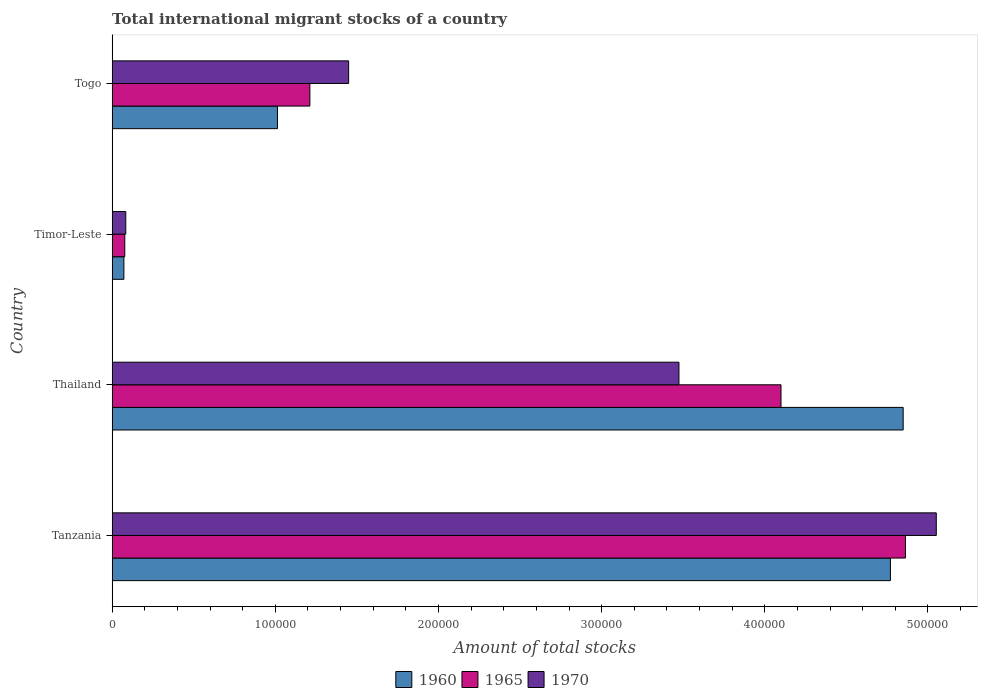How many different coloured bars are there?
Make the answer very short. 3. How many groups of bars are there?
Your answer should be compact. 4. Are the number of bars per tick equal to the number of legend labels?
Provide a succinct answer. Yes. Are the number of bars on each tick of the Y-axis equal?
Provide a succinct answer. Yes. How many bars are there on the 3rd tick from the bottom?
Offer a terse response. 3. What is the label of the 3rd group of bars from the top?
Provide a succinct answer. Thailand. What is the amount of total stocks in in 1965 in Togo?
Give a very brief answer. 1.21e+05. Across all countries, what is the maximum amount of total stocks in in 1965?
Your answer should be very brief. 4.86e+05. Across all countries, what is the minimum amount of total stocks in in 1965?
Ensure brevity in your answer.  7705. In which country was the amount of total stocks in in 1970 maximum?
Your response must be concise. Tanzania. In which country was the amount of total stocks in in 1965 minimum?
Offer a very short reply. Timor-Leste. What is the total amount of total stocks in in 1970 in the graph?
Provide a succinct answer. 1.01e+06. What is the difference between the amount of total stocks in in 1960 in Tanzania and that in Timor-Leste?
Make the answer very short. 4.70e+05. What is the difference between the amount of total stocks in in 1970 in Thailand and the amount of total stocks in in 1965 in Timor-Leste?
Offer a very short reply. 3.40e+05. What is the average amount of total stocks in in 1960 per country?
Provide a short and direct response. 2.68e+05. What is the difference between the amount of total stocks in in 1970 and amount of total stocks in in 1960 in Tanzania?
Provide a succinct answer. 2.81e+04. In how many countries, is the amount of total stocks in in 1965 greater than 260000 ?
Offer a terse response. 2. What is the ratio of the amount of total stocks in in 1970 in Thailand to that in Togo?
Your answer should be very brief. 2.4. What is the difference between the highest and the second highest amount of total stocks in in 1965?
Keep it short and to the point. 7.63e+04. What is the difference between the highest and the lowest amount of total stocks in in 1965?
Your answer should be compact. 4.79e+05. In how many countries, is the amount of total stocks in in 1965 greater than the average amount of total stocks in in 1965 taken over all countries?
Ensure brevity in your answer.  2. Is the sum of the amount of total stocks in in 1965 in Tanzania and Timor-Leste greater than the maximum amount of total stocks in in 1970 across all countries?
Ensure brevity in your answer.  No. How many bars are there?
Provide a short and direct response. 12. How many countries are there in the graph?
Your response must be concise. 4. Are the values on the major ticks of X-axis written in scientific E-notation?
Make the answer very short. No. Does the graph contain any zero values?
Provide a succinct answer. No. Does the graph contain grids?
Ensure brevity in your answer.  No. Where does the legend appear in the graph?
Ensure brevity in your answer.  Bottom center. How are the legend labels stacked?
Provide a succinct answer. Horizontal. What is the title of the graph?
Make the answer very short. Total international migrant stocks of a country. Does "1962" appear as one of the legend labels in the graph?
Your response must be concise. No. What is the label or title of the X-axis?
Offer a terse response. Amount of total stocks. What is the label or title of the Y-axis?
Offer a terse response. Country. What is the Amount of total stocks of 1960 in Tanzania?
Give a very brief answer. 4.77e+05. What is the Amount of total stocks in 1965 in Tanzania?
Provide a succinct answer. 4.86e+05. What is the Amount of total stocks in 1970 in Tanzania?
Provide a succinct answer. 5.05e+05. What is the Amount of total stocks of 1960 in Thailand?
Give a very brief answer. 4.85e+05. What is the Amount of total stocks in 1965 in Thailand?
Offer a very short reply. 4.10e+05. What is the Amount of total stocks of 1970 in Thailand?
Keep it short and to the point. 3.47e+05. What is the Amount of total stocks in 1960 in Timor-Leste?
Make the answer very short. 7148. What is the Amount of total stocks of 1965 in Timor-Leste?
Provide a succinct answer. 7705. What is the Amount of total stocks in 1970 in Timor-Leste?
Offer a very short reply. 8306. What is the Amount of total stocks in 1960 in Togo?
Ensure brevity in your answer.  1.01e+05. What is the Amount of total stocks of 1965 in Togo?
Provide a short and direct response. 1.21e+05. What is the Amount of total stocks in 1970 in Togo?
Offer a very short reply. 1.45e+05. Across all countries, what is the maximum Amount of total stocks in 1960?
Your response must be concise. 4.85e+05. Across all countries, what is the maximum Amount of total stocks in 1965?
Give a very brief answer. 4.86e+05. Across all countries, what is the maximum Amount of total stocks of 1970?
Provide a short and direct response. 5.05e+05. Across all countries, what is the minimum Amount of total stocks of 1960?
Your response must be concise. 7148. Across all countries, what is the minimum Amount of total stocks of 1965?
Offer a terse response. 7705. Across all countries, what is the minimum Amount of total stocks of 1970?
Offer a terse response. 8306. What is the total Amount of total stocks of 1960 in the graph?
Keep it short and to the point. 1.07e+06. What is the total Amount of total stocks of 1965 in the graph?
Offer a terse response. 1.03e+06. What is the total Amount of total stocks in 1970 in the graph?
Your answer should be compact. 1.01e+06. What is the difference between the Amount of total stocks of 1960 in Tanzania and that in Thailand?
Your answer should be very brief. -7812. What is the difference between the Amount of total stocks in 1965 in Tanzania and that in Thailand?
Make the answer very short. 7.63e+04. What is the difference between the Amount of total stocks of 1970 in Tanzania and that in Thailand?
Your response must be concise. 1.58e+05. What is the difference between the Amount of total stocks of 1960 in Tanzania and that in Timor-Leste?
Make the answer very short. 4.70e+05. What is the difference between the Amount of total stocks of 1965 in Tanzania and that in Timor-Leste?
Ensure brevity in your answer.  4.79e+05. What is the difference between the Amount of total stocks of 1970 in Tanzania and that in Timor-Leste?
Offer a very short reply. 4.97e+05. What is the difference between the Amount of total stocks in 1960 in Tanzania and that in Togo?
Ensure brevity in your answer.  3.76e+05. What is the difference between the Amount of total stocks in 1965 in Tanzania and that in Togo?
Provide a short and direct response. 3.65e+05. What is the difference between the Amount of total stocks of 1970 in Tanzania and that in Togo?
Your response must be concise. 3.60e+05. What is the difference between the Amount of total stocks in 1960 in Thailand and that in Timor-Leste?
Give a very brief answer. 4.78e+05. What is the difference between the Amount of total stocks in 1965 in Thailand and that in Timor-Leste?
Your answer should be very brief. 4.02e+05. What is the difference between the Amount of total stocks in 1970 in Thailand and that in Timor-Leste?
Offer a terse response. 3.39e+05. What is the difference between the Amount of total stocks in 1960 in Thailand and that in Togo?
Provide a succinct answer. 3.84e+05. What is the difference between the Amount of total stocks of 1965 in Thailand and that in Togo?
Offer a terse response. 2.89e+05. What is the difference between the Amount of total stocks of 1970 in Thailand and that in Togo?
Give a very brief answer. 2.02e+05. What is the difference between the Amount of total stocks in 1960 in Timor-Leste and that in Togo?
Your response must be concise. -9.41e+04. What is the difference between the Amount of total stocks in 1965 in Timor-Leste and that in Togo?
Provide a short and direct response. -1.13e+05. What is the difference between the Amount of total stocks in 1970 in Timor-Leste and that in Togo?
Your response must be concise. -1.37e+05. What is the difference between the Amount of total stocks of 1960 in Tanzania and the Amount of total stocks of 1965 in Thailand?
Your answer should be very brief. 6.71e+04. What is the difference between the Amount of total stocks in 1960 in Tanzania and the Amount of total stocks in 1970 in Thailand?
Make the answer very short. 1.30e+05. What is the difference between the Amount of total stocks of 1965 in Tanzania and the Amount of total stocks of 1970 in Thailand?
Provide a short and direct response. 1.39e+05. What is the difference between the Amount of total stocks in 1960 in Tanzania and the Amount of total stocks in 1965 in Timor-Leste?
Your response must be concise. 4.69e+05. What is the difference between the Amount of total stocks in 1960 in Tanzania and the Amount of total stocks in 1970 in Timor-Leste?
Offer a terse response. 4.69e+05. What is the difference between the Amount of total stocks in 1965 in Tanzania and the Amount of total stocks in 1970 in Timor-Leste?
Your answer should be compact. 4.78e+05. What is the difference between the Amount of total stocks in 1960 in Tanzania and the Amount of total stocks in 1965 in Togo?
Provide a short and direct response. 3.56e+05. What is the difference between the Amount of total stocks of 1960 in Tanzania and the Amount of total stocks of 1970 in Togo?
Keep it short and to the point. 3.32e+05. What is the difference between the Amount of total stocks of 1965 in Tanzania and the Amount of total stocks of 1970 in Togo?
Keep it short and to the point. 3.41e+05. What is the difference between the Amount of total stocks of 1960 in Thailand and the Amount of total stocks of 1965 in Timor-Leste?
Ensure brevity in your answer.  4.77e+05. What is the difference between the Amount of total stocks in 1960 in Thailand and the Amount of total stocks in 1970 in Timor-Leste?
Ensure brevity in your answer.  4.77e+05. What is the difference between the Amount of total stocks of 1965 in Thailand and the Amount of total stocks of 1970 in Timor-Leste?
Your answer should be very brief. 4.02e+05. What is the difference between the Amount of total stocks in 1960 in Thailand and the Amount of total stocks in 1965 in Togo?
Provide a short and direct response. 3.64e+05. What is the difference between the Amount of total stocks in 1960 in Thailand and the Amount of total stocks in 1970 in Togo?
Provide a succinct answer. 3.40e+05. What is the difference between the Amount of total stocks of 1965 in Thailand and the Amount of total stocks of 1970 in Togo?
Offer a terse response. 2.65e+05. What is the difference between the Amount of total stocks in 1960 in Timor-Leste and the Amount of total stocks in 1965 in Togo?
Ensure brevity in your answer.  -1.14e+05. What is the difference between the Amount of total stocks of 1960 in Timor-Leste and the Amount of total stocks of 1970 in Togo?
Ensure brevity in your answer.  -1.38e+05. What is the difference between the Amount of total stocks of 1965 in Timor-Leste and the Amount of total stocks of 1970 in Togo?
Ensure brevity in your answer.  -1.37e+05. What is the average Amount of total stocks in 1960 per country?
Give a very brief answer. 2.68e+05. What is the average Amount of total stocks of 1965 per country?
Keep it short and to the point. 2.56e+05. What is the average Amount of total stocks of 1970 per country?
Your response must be concise. 2.51e+05. What is the difference between the Amount of total stocks in 1960 and Amount of total stocks in 1965 in Tanzania?
Your response must be concise. -9214. What is the difference between the Amount of total stocks in 1960 and Amount of total stocks in 1970 in Tanzania?
Your answer should be very brief. -2.81e+04. What is the difference between the Amount of total stocks in 1965 and Amount of total stocks in 1970 in Tanzania?
Provide a succinct answer. -1.89e+04. What is the difference between the Amount of total stocks in 1960 and Amount of total stocks in 1965 in Thailand?
Offer a terse response. 7.49e+04. What is the difference between the Amount of total stocks in 1960 and Amount of total stocks in 1970 in Thailand?
Your response must be concise. 1.37e+05. What is the difference between the Amount of total stocks of 1965 and Amount of total stocks of 1970 in Thailand?
Your answer should be compact. 6.26e+04. What is the difference between the Amount of total stocks in 1960 and Amount of total stocks in 1965 in Timor-Leste?
Ensure brevity in your answer.  -557. What is the difference between the Amount of total stocks of 1960 and Amount of total stocks of 1970 in Timor-Leste?
Provide a short and direct response. -1158. What is the difference between the Amount of total stocks in 1965 and Amount of total stocks in 1970 in Timor-Leste?
Give a very brief answer. -601. What is the difference between the Amount of total stocks of 1960 and Amount of total stocks of 1965 in Togo?
Keep it short and to the point. -1.99e+04. What is the difference between the Amount of total stocks in 1960 and Amount of total stocks in 1970 in Togo?
Your response must be concise. -4.36e+04. What is the difference between the Amount of total stocks of 1965 and Amount of total stocks of 1970 in Togo?
Give a very brief answer. -2.38e+04. What is the ratio of the Amount of total stocks of 1960 in Tanzania to that in Thailand?
Provide a succinct answer. 0.98. What is the ratio of the Amount of total stocks of 1965 in Tanzania to that in Thailand?
Make the answer very short. 1.19. What is the ratio of the Amount of total stocks in 1970 in Tanzania to that in Thailand?
Your response must be concise. 1.45. What is the ratio of the Amount of total stocks in 1960 in Tanzania to that in Timor-Leste?
Offer a very short reply. 66.74. What is the ratio of the Amount of total stocks of 1965 in Tanzania to that in Timor-Leste?
Your answer should be compact. 63.11. What is the ratio of the Amount of total stocks of 1970 in Tanzania to that in Timor-Leste?
Ensure brevity in your answer.  60.82. What is the ratio of the Amount of total stocks in 1960 in Tanzania to that in Togo?
Your response must be concise. 4.71. What is the ratio of the Amount of total stocks of 1965 in Tanzania to that in Togo?
Provide a short and direct response. 4.01. What is the ratio of the Amount of total stocks of 1970 in Tanzania to that in Togo?
Offer a very short reply. 3.49. What is the ratio of the Amount of total stocks of 1960 in Thailand to that in Timor-Leste?
Your answer should be very brief. 67.83. What is the ratio of the Amount of total stocks in 1965 in Thailand to that in Timor-Leste?
Your answer should be very brief. 53.21. What is the ratio of the Amount of total stocks of 1970 in Thailand to that in Timor-Leste?
Your response must be concise. 41.82. What is the ratio of the Amount of total stocks in 1960 in Thailand to that in Togo?
Offer a very short reply. 4.79. What is the ratio of the Amount of total stocks in 1965 in Thailand to that in Togo?
Keep it short and to the point. 3.38. What is the ratio of the Amount of total stocks of 1970 in Thailand to that in Togo?
Your answer should be very brief. 2.4. What is the ratio of the Amount of total stocks in 1960 in Timor-Leste to that in Togo?
Give a very brief answer. 0.07. What is the ratio of the Amount of total stocks in 1965 in Timor-Leste to that in Togo?
Make the answer very short. 0.06. What is the ratio of the Amount of total stocks in 1970 in Timor-Leste to that in Togo?
Provide a short and direct response. 0.06. What is the difference between the highest and the second highest Amount of total stocks of 1960?
Keep it short and to the point. 7812. What is the difference between the highest and the second highest Amount of total stocks of 1965?
Provide a short and direct response. 7.63e+04. What is the difference between the highest and the second highest Amount of total stocks in 1970?
Your answer should be compact. 1.58e+05. What is the difference between the highest and the lowest Amount of total stocks in 1960?
Give a very brief answer. 4.78e+05. What is the difference between the highest and the lowest Amount of total stocks in 1965?
Provide a succinct answer. 4.79e+05. What is the difference between the highest and the lowest Amount of total stocks of 1970?
Your answer should be compact. 4.97e+05. 